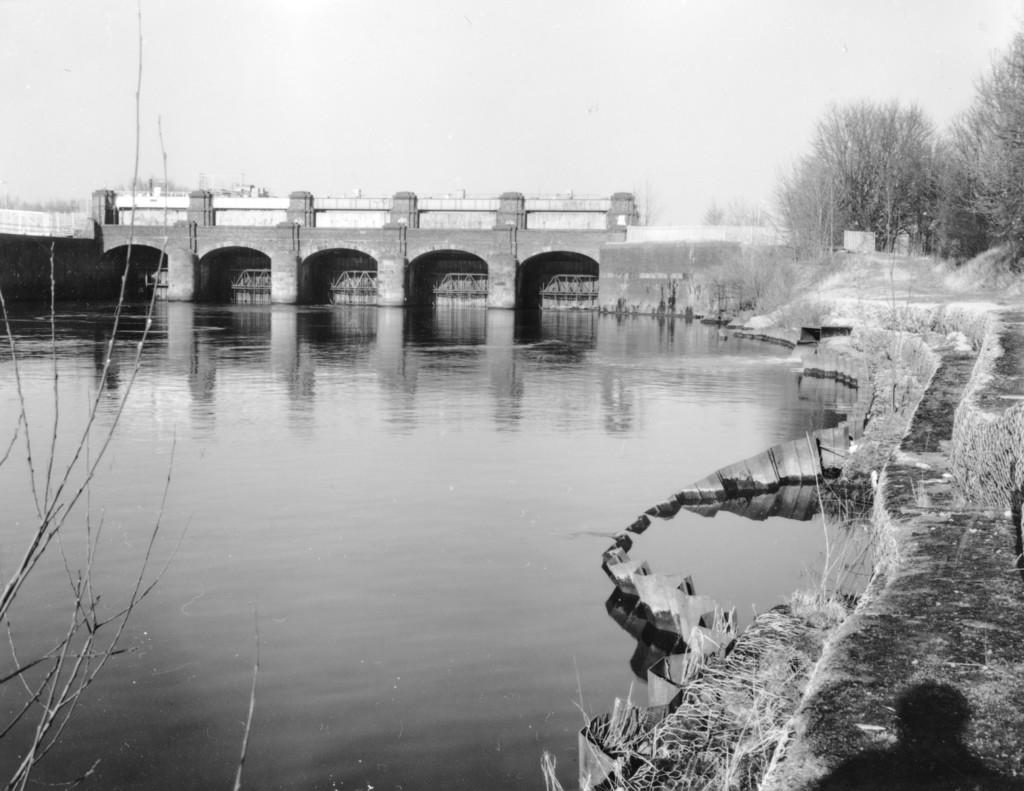What is the color scheme of the image? The image is black and white. What is the main structure in the image? There is a bridge in the center of the image. What can be seen flowing beneath the bridge? There is water visible in the image. What architectural feature is on the right side of the image? There is a staircase on the right side of the image. What type of vegetation is present in the image? There are trees in the image. What type of bait is being used to catch fish in the image? There is no fishing activity or bait present in the image. Can you see any wires or cables attached to the bridge in the image? The image is in black and white, so it is difficult to determine if there are any wires or cables attached to the bridge. However, the focus of the image is on the bridge and its surroundings, not on any specific details like wires or cables. Is there a plane flying over the bridge in the image? There is no plane visible in the image. 